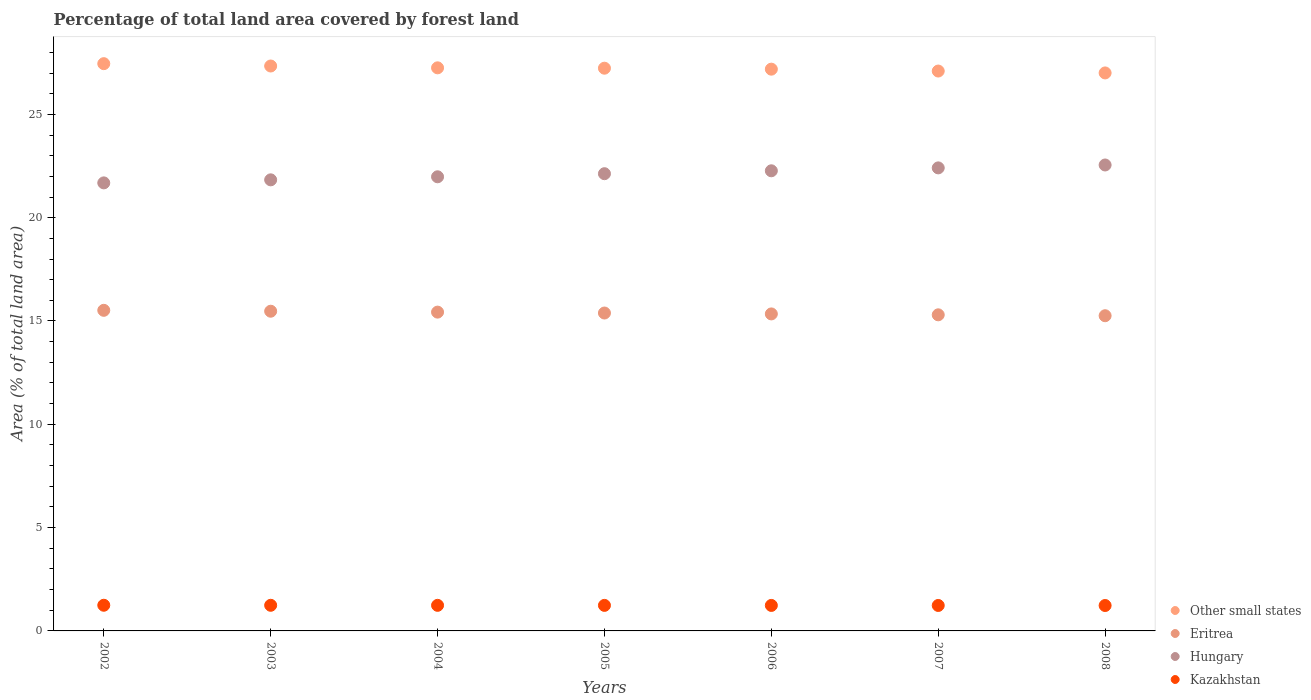How many different coloured dotlines are there?
Make the answer very short. 4. Is the number of dotlines equal to the number of legend labels?
Offer a very short reply. Yes. What is the percentage of forest land in Eritrea in 2002?
Give a very brief answer. 15.52. Across all years, what is the maximum percentage of forest land in Kazakhstan?
Your answer should be compact. 1.24. Across all years, what is the minimum percentage of forest land in Hungary?
Ensure brevity in your answer.  21.68. In which year was the percentage of forest land in Hungary maximum?
Give a very brief answer. 2008. In which year was the percentage of forest land in Kazakhstan minimum?
Your answer should be compact. 2008. What is the total percentage of forest land in Hungary in the graph?
Provide a short and direct response. 154.86. What is the difference between the percentage of forest land in Kazakhstan in 2002 and that in 2003?
Provide a succinct answer. 0. What is the difference between the percentage of forest land in Hungary in 2004 and the percentage of forest land in Other small states in 2008?
Provide a succinct answer. -5.03. What is the average percentage of forest land in Kazakhstan per year?
Make the answer very short. 1.24. In the year 2006, what is the difference between the percentage of forest land in Eritrea and percentage of forest land in Other small states?
Offer a very short reply. -11.85. What is the ratio of the percentage of forest land in Hungary in 2003 to that in 2007?
Make the answer very short. 0.97. Is the difference between the percentage of forest land in Eritrea in 2002 and 2005 greater than the difference between the percentage of forest land in Other small states in 2002 and 2005?
Ensure brevity in your answer.  No. What is the difference between the highest and the second highest percentage of forest land in Hungary?
Offer a terse response. 0.14. What is the difference between the highest and the lowest percentage of forest land in Eritrea?
Keep it short and to the point. 0.26. Is the sum of the percentage of forest land in Other small states in 2003 and 2005 greater than the maximum percentage of forest land in Hungary across all years?
Your answer should be very brief. Yes. Does the percentage of forest land in Other small states monotonically increase over the years?
Your answer should be compact. No. Is the percentage of forest land in Hungary strictly greater than the percentage of forest land in Other small states over the years?
Keep it short and to the point. No. Does the graph contain grids?
Provide a succinct answer. No. Where does the legend appear in the graph?
Make the answer very short. Bottom right. How many legend labels are there?
Provide a succinct answer. 4. How are the legend labels stacked?
Your answer should be very brief. Vertical. What is the title of the graph?
Keep it short and to the point. Percentage of total land area covered by forest land. What is the label or title of the X-axis?
Your answer should be very brief. Years. What is the label or title of the Y-axis?
Provide a succinct answer. Area (% of total land area). What is the Area (% of total land area) in Other small states in 2002?
Give a very brief answer. 27.45. What is the Area (% of total land area) of Eritrea in 2002?
Give a very brief answer. 15.52. What is the Area (% of total land area) in Hungary in 2002?
Provide a short and direct response. 21.68. What is the Area (% of total land area) in Kazakhstan in 2002?
Your response must be concise. 1.24. What is the Area (% of total land area) in Other small states in 2003?
Your response must be concise. 27.34. What is the Area (% of total land area) of Eritrea in 2003?
Your answer should be very brief. 15.47. What is the Area (% of total land area) in Hungary in 2003?
Offer a very short reply. 21.83. What is the Area (% of total land area) of Kazakhstan in 2003?
Offer a terse response. 1.24. What is the Area (% of total land area) in Other small states in 2004?
Ensure brevity in your answer.  27.25. What is the Area (% of total land area) in Eritrea in 2004?
Provide a succinct answer. 15.43. What is the Area (% of total land area) in Hungary in 2004?
Offer a very short reply. 21.98. What is the Area (% of total land area) of Kazakhstan in 2004?
Offer a terse response. 1.24. What is the Area (% of total land area) in Other small states in 2005?
Ensure brevity in your answer.  27.24. What is the Area (% of total land area) of Eritrea in 2005?
Make the answer very short. 15.39. What is the Area (% of total land area) in Hungary in 2005?
Provide a short and direct response. 22.13. What is the Area (% of total land area) in Kazakhstan in 2005?
Provide a short and direct response. 1.24. What is the Area (% of total land area) in Other small states in 2006?
Give a very brief answer. 27.19. What is the Area (% of total land area) of Eritrea in 2006?
Your answer should be compact. 15.34. What is the Area (% of total land area) in Hungary in 2006?
Ensure brevity in your answer.  22.27. What is the Area (% of total land area) of Kazakhstan in 2006?
Your answer should be compact. 1.23. What is the Area (% of total land area) of Other small states in 2007?
Keep it short and to the point. 27.1. What is the Area (% of total land area) in Eritrea in 2007?
Keep it short and to the point. 15.3. What is the Area (% of total land area) of Hungary in 2007?
Offer a very short reply. 22.41. What is the Area (% of total land area) of Kazakhstan in 2007?
Make the answer very short. 1.23. What is the Area (% of total land area) of Other small states in 2008?
Your response must be concise. 27.01. What is the Area (% of total land area) in Eritrea in 2008?
Your answer should be very brief. 15.26. What is the Area (% of total land area) in Hungary in 2008?
Give a very brief answer. 22.55. What is the Area (% of total land area) in Kazakhstan in 2008?
Offer a very short reply. 1.23. Across all years, what is the maximum Area (% of total land area) of Other small states?
Make the answer very short. 27.45. Across all years, what is the maximum Area (% of total land area) of Eritrea?
Offer a very short reply. 15.52. Across all years, what is the maximum Area (% of total land area) in Hungary?
Make the answer very short. 22.55. Across all years, what is the maximum Area (% of total land area) of Kazakhstan?
Provide a short and direct response. 1.24. Across all years, what is the minimum Area (% of total land area) of Other small states?
Give a very brief answer. 27.01. Across all years, what is the minimum Area (% of total land area) in Eritrea?
Your answer should be very brief. 15.26. Across all years, what is the minimum Area (% of total land area) in Hungary?
Offer a very short reply. 21.68. Across all years, what is the minimum Area (% of total land area) in Kazakhstan?
Your response must be concise. 1.23. What is the total Area (% of total land area) of Other small states in the graph?
Your answer should be very brief. 190.58. What is the total Area (% of total land area) in Eritrea in the graph?
Your response must be concise. 107.7. What is the total Area (% of total land area) of Hungary in the graph?
Provide a succinct answer. 154.86. What is the total Area (% of total land area) of Kazakhstan in the graph?
Provide a succinct answer. 8.65. What is the difference between the Area (% of total land area) in Other small states in 2002 and that in 2003?
Offer a terse response. 0.11. What is the difference between the Area (% of total land area) in Eritrea in 2002 and that in 2003?
Provide a succinct answer. 0.04. What is the difference between the Area (% of total land area) of Hungary in 2002 and that in 2003?
Your answer should be very brief. -0.15. What is the difference between the Area (% of total land area) in Kazakhstan in 2002 and that in 2003?
Your response must be concise. 0. What is the difference between the Area (% of total land area) in Other small states in 2002 and that in 2004?
Offer a very short reply. 0.2. What is the difference between the Area (% of total land area) of Eritrea in 2002 and that in 2004?
Provide a short and direct response. 0.09. What is the difference between the Area (% of total land area) of Hungary in 2002 and that in 2004?
Keep it short and to the point. -0.29. What is the difference between the Area (% of total land area) of Kazakhstan in 2002 and that in 2004?
Provide a succinct answer. 0. What is the difference between the Area (% of total land area) of Other small states in 2002 and that in 2005?
Offer a terse response. 0.22. What is the difference between the Area (% of total land area) of Eritrea in 2002 and that in 2005?
Offer a terse response. 0.13. What is the difference between the Area (% of total land area) in Hungary in 2002 and that in 2005?
Provide a short and direct response. -0.44. What is the difference between the Area (% of total land area) in Kazakhstan in 2002 and that in 2005?
Make the answer very short. 0.01. What is the difference between the Area (% of total land area) in Other small states in 2002 and that in 2006?
Your response must be concise. 0.27. What is the difference between the Area (% of total land area) of Eritrea in 2002 and that in 2006?
Make the answer very short. 0.17. What is the difference between the Area (% of total land area) of Hungary in 2002 and that in 2006?
Your response must be concise. -0.58. What is the difference between the Area (% of total land area) of Kazakhstan in 2002 and that in 2006?
Provide a succinct answer. 0.01. What is the difference between the Area (% of total land area) of Other small states in 2002 and that in 2007?
Keep it short and to the point. 0.36. What is the difference between the Area (% of total land area) of Eritrea in 2002 and that in 2007?
Offer a very short reply. 0.22. What is the difference between the Area (% of total land area) in Hungary in 2002 and that in 2007?
Provide a short and direct response. -0.73. What is the difference between the Area (% of total land area) of Kazakhstan in 2002 and that in 2007?
Provide a succinct answer. 0.01. What is the difference between the Area (% of total land area) of Other small states in 2002 and that in 2008?
Offer a very short reply. 0.45. What is the difference between the Area (% of total land area) in Eritrea in 2002 and that in 2008?
Provide a short and direct response. 0.26. What is the difference between the Area (% of total land area) in Hungary in 2002 and that in 2008?
Make the answer very short. -0.87. What is the difference between the Area (% of total land area) of Kazakhstan in 2002 and that in 2008?
Keep it short and to the point. 0.01. What is the difference between the Area (% of total land area) of Other small states in 2003 and that in 2004?
Provide a succinct answer. 0.09. What is the difference between the Area (% of total land area) in Eritrea in 2003 and that in 2004?
Your response must be concise. 0.04. What is the difference between the Area (% of total land area) in Hungary in 2003 and that in 2004?
Ensure brevity in your answer.  -0.15. What is the difference between the Area (% of total land area) of Kazakhstan in 2003 and that in 2004?
Offer a terse response. 0. What is the difference between the Area (% of total land area) in Other small states in 2003 and that in 2005?
Offer a very short reply. 0.11. What is the difference between the Area (% of total land area) in Eritrea in 2003 and that in 2005?
Provide a short and direct response. 0.09. What is the difference between the Area (% of total land area) of Hungary in 2003 and that in 2005?
Your answer should be very brief. -0.3. What is the difference between the Area (% of total land area) in Kazakhstan in 2003 and that in 2005?
Offer a very short reply. 0. What is the difference between the Area (% of total land area) in Other small states in 2003 and that in 2006?
Your answer should be very brief. 0.15. What is the difference between the Area (% of total land area) of Eritrea in 2003 and that in 2006?
Your answer should be compact. 0.13. What is the difference between the Area (% of total land area) of Hungary in 2003 and that in 2006?
Make the answer very short. -0.44. What is the difference between the Area (% of total land area) in Kazakhstan in 2003 and that in 2006?
Ensure brevity in your answer.  0.01. What is the difference between the Area (% of total land area) in Other small states in 2003 and that in 2007?
Your response must be concise. 0.24. What is the difference between the Area (% of total land area) of Eritrea in 2003 and that in 2007?
Make the answer very short. 0.17. What is the difference between the Area (% of total land area) of Hungary in 2003 and that in 2007?
Your response must be concise. -0.58. What is the difference between the Area (% of total land area) of Kazakhstan in 2003 and that in 2007?
Make the answer very short. 0.01. What is the difference between the Area (% of total land area) in Other small states in 2003 and that in 2008?
Keep it short and to the point. 0.34. What is the difference between the Area (% of total land area) of Eritrea in 2003 and that in 2008?
Your answer should be very brief. 0.22. What is the difference between the Area (% of total land area) of Hungary in 2003 and that in 2008?
Offer a very short reply. -0.72. What is the difference between the Area (% of total land area) of Kazakhstan in 2003 and that in 2008?
Provide a succinct answer. 0.01. What is the difference between the Area (% of total land area) in Other small states in 2004 and that in 2005?
Give a very brief answer. 0.02. What is the difference between the Area (% of total land area) of Eritrea in 2004 and that in 2005?
Your answer should be compact. 0.04. What is the difference between the Area (% of total land area) in Hungary in 2004 and that in 2005?
Offer a terse response. -0.15. What is the difference between the Area (% of total land area) in Kazakhstan in 2004 and that in 2005?
Your answer should be very brief. 0. What is the difference between the Area (% of total land area) in Other small states in 2004 and that in 2006?
Your answer should be compact. 0.06. What is the difference between the Area (% of total land area) of Eritrea in 2004 and that in 2006?
Offer a very short reply. 0.09. What is the difference between the Area (% of total land area) of Hungary in 2004 and that in 2006?
Your response must be concise. -0.29. What is the difference between the Area (% of total land area) in Kazakhstan in 2004 and that in 2006?
Make the answer very short. 0. What is the difference between the Area (% of total land area) in Other small states in 2004 and that in 2007?
Make the answer very short. 0.16. What is the difference between the Area (% of total land area) of Eritrea in 2004 and that in 2007?
Offer a terse response. 0.13. What is the difference between the Area (% of total land area) of Hungary in 2004 and that in 2007?
Your answer should be very brief. -0.43. What is the difference between the Area (% of total land area) in Kazakhstan in 2004 and that in 2007?
Offer a very short reply. 0.01. What is the difference between the Area (% of total land area) of Other small states in 2004 and that in 2008?
Keep it short and to the point. 0.25. What is the difference between the Area (% of total land area) in Eritrea in 2004 and that in 2008?
Provide a short and direct response. 0.17. What is the difference between the Area (% of total land area) of Hungary in 2004 and that in 2008?
Make the answer very short. -0.57. What is the difference between the Area (% of total land area) of Kazakhstan in 2004 and that in 2008?
Your answer should be compact. 0.01. What is the difference between the Area (% of total land area) of Other small states in 2005 and that in 2006?
Ensure brevity in your answer.  0.05. What is the difference between the Area (% of total land area) of Eritrea in 2005 and that in 2006?
Provide a short and direct response. 0.04. What is the difference between the Area (% of total land area) in Hungary in 2005 and that in 2006?
Offer a very short reply. -0.14. What is the difference between the Area (% of total land area) in Kazakhstan in 2005 and that in 2006?
Provide a succinct answer. 0. What is the difference between the Area (% of total land area) in Other small states in 2005 and that in 2007?
Offer a very short reply. 0.14. What is the difference between the Area (% of total land area) in Eritrea in 2005 and that in 2007?
Keep it short and to the point. 0.09. What is the difference between the Area (% of total land area) in Hungary in 2005 and that in 2007?
Give a very brief answer. -0.28. What is the difference between the Area (% of total land area) in Kazakhstan in 2005 and that in 2007?
Your answer should be very brief. 0. What is the difference between the Area (% of total land area) of Other small states in 2005 and that in 2008?
Offer a very short reply. 0.23. What is the difference between the Area (% of total land area) of Eritrea in 2005 and that in 2008?
Ensure brevity in your answer.  0.13. What is the difference between the Area (% of total land area) of Hungary in 2005 and that in 2008?
Keep it short and to the point. -0.42. What is the difference between the Area (% of total land area) of Kazakhstan in 2005 and that in 2008?
Your response must be concise. 0.01. What is the difference between the Area (% of total land area) of Other small states in 2006 and that in 2007?
Ensure brevity in your answer.  0.09. What is the difference between the Area (% of total land area) in Eritrea in 2006 and that in 2007?
Ensure brevity in your answer.  0.04. What is the difference between the Area (% of total land area) of Hungary in 2006 and that in 2007?
Provide a short and direct response. -0.14. What is the difference between the Area (% of total land area) of Kazakhstan in 2006 and that in 2007?
Make the answer very short. 0. What is the difference between the Area (% of total land area) of Other small states in 2006 and that in 2008?
Provide a succinct answer. 0.18. What is the difference between the Area (% of total land area) in Eritrea in 2006 and that in 2008?
Your response must be concise. 0.09. What is the difference between the Area (% of total land area) of Hungary in 2006 and that in 2008?
Make the answer very short. -0.28. What is the difference between the Area (% of total land area) of Kazakhstan in 2006 and that in 2008?
Offer a very short reply. 0. What is the difference between the Area (% of total land area) in Other small states in 2007 and that in 2008?
Offer a terse response. 0.09. What is the difference between the Area (% of total land area) in Eritrea in 2007 and that in 2008?
Ensure brevity in your answer.  0.04. What is the difference between the Area (% of total land area) in Hungary in 2007 and that in 2008?
Your answer should be very brief. -0.14. What is the difference between the Area (% of total land area) in Kazakhstan in 2007 and that in 2008?
Keep it short and to the point. 0. What is the difference between the Area (% of total land area) of Other small states in 2002 and the Area (% of total land area) of Eritrea in 2003?
Provide a short and direct response. 11.98. What is the difference between the Area (% of total land area) of Other small states in 2002 and the Area (% of total land area) of Hungary in 2003?
Keep it short and to the point. 5.62. What is the difference between the Area (% of total land area) in Other small states in 2002 and the Area (% of total land area) in Kazakhstan in 2003?
Make the answer very short. 26.21. What is the difference between the Area (% of total land area) in Eritrea in 2002 and the Area (% of total land area) in Hungary in 2003?
Offer a terse response. -6.32. What is the difference between the Area (% of total land area) of Eritrea in 2002 and the Area (% of total land area) of Kazakhstan in 2003?
Your response must be concise. 14.28. What is the difference between the Area (% of total land area) in Hungary in 2002 and the Area (% of total land area) in Kazakhstan in 2003?
Keep it short and to the point. 20.44. What is the difference between the Area (% of total land area) of Other small states in 2002 and the Area (% of total land area) of Eritrea in 2004?
Provide a succinct answer. 12.03. What is the difference between the Area (% of total land area) in Other small states in 2002 and the Area (% of total land area) in Hungary in 2004?
Keep it short and to the point. 5.48. What is the difference between the Area (% of total land area) of Other small states in 2002 and the Area (% of total land area) of Kazakhstan in 2004?
Ensure brevity in your answer.  26.22. What is the difference between the Area (% of total land area) in Eritrea in 2002 and the Area (% of total land area) in Hungary in 2004?
Your answer should be compact. -6.46. What is the difference between the Area (% of total land area) in Eritrea in 2002 and the Area (% of total land area) in Kazakhstan in 2004?
Provide a short and direct response. 14.28. What is the difference between the Area (% of total land area) in Hungary in 2002 and the Area (% of total land area) in Kazakhstan in 2004?
Offer a very short reply. 20.45. What is the difference between the Area (% of total land area) in Other small states in 2002 and the Area (% of total land area) in Eritrea in 2005?
Ensure brevity in your answer.  12.07. What is the difference between the Area (% of total land area) of Other small states in 2002 and the Area (% of total land area) of Hungary in 2005?
Ensure brevity in your answer.  5.33. What is the difference between the Area (% of total land area) of Other small states in 2002 and the Area (% of total land area) of Kazakhstan in 2005?
Offer a very short reply. 26.22. What is the difference between the Area (% of total land area) in Eritrea in 2002 and the Area (% of total land area) in Hungary in 2005?
Provide a short and direct response. -6.61. What is the difference between the Area (% of total land area) of Eritrea in 2002 and the Area (% of total land area) of Kazakhstan in 2005?
Ensure brevity in your answer.  14.28. What is the difference between the Area (% of total land area) of Hungary in 2002 and the Area (% of total land area) of Kazakhstan in 2005?
Your response must be concise. 20.45. What is the difference between the Area (% of total land area) of Other small states in 2002 and the Area (% of total land area) of Eritrea in 2006?
Give a very brief answer. 12.11. What is the difference between the Area (% of total land area) of Other small states in 2002 and the Area (% of total land area) of Hungary in 2006?
Offer a terse response. 5.18. What is the difference between the Area (% of total land area) of Other small states in 2002 and the Area (% of total land area) of Kazakhstan in 2006?
Provide a succinct answer. 26.22. What is the difference between the Area (% of total land area) in Eritrea in 2002 and the Area (% of total land area) in Hungary in 2006?
Keep it short and to the point. -6.75. What is the difference between the Area (% of total land area) in Eritrea in 2002 and the Area (% of total land area) in Kazakhstan in 2006?
Keep it short and to the point. 14.28. What is the difference between the Area (% of total land area) of Hungary in 2002 and the Area (% of total land area) of Kazakhstan in 2006?
Your response must be concise. 20.45. What is the difference between the Area (% of total land area) in Other small states in 2002 and the Area (% of total land area) in Eritrea in 2007?
Keep it short and to the point. 12.16. What is the difference between the Area (% of total land area) of Other small states in 2002 and the Area (% of total land area) of Hungary in 2007?
Offer a very short reply. 5.04. What is the difference between the Area (% of total land area) in Other small states in 2002 and the Area (% of total land area) in Kazakhstan in 2007?
Offer a very short reply. 26.22. What is the difference between the Area (% of total land area) in Eritrea in 2002 and the Area (% of total land area) in Hungary in 2007?
Keep it short and to the point. -6.89. What is the difference between the Area (% of total land area) of Eritrea in 2002 and the Area (% of total land area) of Kazakhstan in 2007?
Give a very brief answer. 14.28. What is the difference between the Area (% of total land area) of Hungary in 2002 and the Area (% of total land area) of Kazakhstan in 2007?
Keep it short and to the point. 20.45. What is the difference between the Area (% of total land area) of Other small states in 2002 and the Area (% of total land area) of Eritrea in 2008?
Your answer should be very brief. 12.2. What is the difference between the Area (% of total land area) of Other small states in 2002 and the Area (% of total land area) of Hungary in 2008?
Your answer should be compact. 4.9. What is the difference between the Area (% of total land area) in Other small states in 2002 and the Area (% of total land area) in Kazakhstan in 2008?
Provide a short and direct response. 26.22. What is the difference between the Area (% of total land area) of Eritrea in 2002 and the Area (% of total land area) of Hungary in 2008?
Your response must be concise. -7.03. What is the difference between the Area (% of total land area) in Eritrea in 2002 and the Area (% of total land area) in Kazakhstan in 2008?
Offer a very short reply. 14.29. What is the difference between the Area (% of total land area) in Hungary in 2002 and the Area (% of total land area) in Kazakhstan in 2008?
Offer a terse response. 20.46. What is the difference between the Area (% of total land area) in Other small states in 2003 and the Area (% of total land area) in Eritrea in 2004?
Ensure brevity in your answer.  11.91. What is the difference between the Area (% of total land area) of Other small states in 2003 and the Area (% of total land area) of Hungary in 2004?
Provide a short and direct response. 5.36. What is the difference between the Area (% of total land area) of Other small states in 2003 and the Area (% of total land area) of Kazakhstan in 2004?
Ensure brevity in your answer.  26.1. What is the difference between the Area (% of total land area) in Eritrea in 2003 and the Area (% of total land area) in Hungary in 2004?
Offer a terse response. -6.51. What is the difference between the Area (% of total land area) in Eritrea in 2003 and the Area (% of total land area) in Kazakhstan in 2004?
Provide a succinct answer. 14.24. What is the difference between the Area (% of total land area) of Hungary in 2003 and the Area (% of total land area) of Kazakhstan in 2004?
Provide a short and direct response. 20.59. What is the difference between the Area (% of total land area) in Other small states in 2003 and the Area (% of total land area) in Eritrea in 2005?
Keep it short and to the point. 11.96. What is the difference between the Area (% of total land area) of Other small states in 2003 and the Area (% of total land area) of Hungary in 2005?
Give a very brief answer. 5.21. What is the difference between the Area (% of total land area) in Other small states in 2003 and the Area (% of total land area) in Kazakhstan in 2005?
Provide a succinct answer. 26.11. What is the difference between the Area (% of total land area) in Eritrea in 2003 and the Area (% of total land area) in Hungary in 2005?
Offer a terse response. -6.66. What is the difference between the Area (% of total land area) in Eritrea in 2003 and the Area (% of total land area) in Kazakhstan in 2005?
Ensure brevity in your answer.  14.24. What is the difference between the Area (% of total land area) in Hungary in 2003 and the Area (% of total land area) in Kazakhstan in 2005?
Ensure brevity in your answer.  20.6. What is the difference between the Area (% of total land area) in Other small states in 2003 and the Area (% of total land area) in Eritrea in 2006?
Ensure brevity in your answer.  12. What is the difference between the Area (% of total land area) in Other small states in 2003 and the Area (% of total land area) in Hungary in 2006?
Make the answer very short. 5.07. What is the difference between the Area (% of total land area) in Other small states in 2003 and the Area (% of total land area) in Kazakhstan in 2006?
Your response must be concise. 26.11. What is the difference between the Area (% of total land area) in Eritrea in 2003 and the Area (% of total land area) in Hungary in 2006?
Provide a short and direct response. -6.8. What is the difference between the Area (% of total land area) in Eritrea in 2003 and the Area (% of total land area) in Kazakhstan in 2006?
Make the answer very short. 14.24. What is the difference between the Area (% of total land area) of Hungary in 2003 and the Area (% of total land area) of Kazakhstan in 2006?
Your answer should be compact. 20.6. What is the difference between the Area (% of total land area) in Other small states in 2003 and the Area (% of total land area) in Eritrea in 2007?
Make the answer very short. 12.04. What is the difference between the Area (% of total land area) in Other small states in 2003 and the Area (% of total land area) in Hungary in 2007?
Your response must be concise. 4.93. What is the difference between the Area (% of total land area) of Other small states in 2003 and the Area (% of total land area) of Kazakhstan in 2007?
Your answer should be compact. 26.11. What is the difference between the Area (% of total land area) of Eritrea in 2003 and the Area (% of total land area) of Hungary in 2007?
Offer a terse response. -6.94. What is the difference between the Area (% of total land area) of Eritrea in 2003 and the Area (% of total land area) of Kazakhstan in 2007?
Make the answer very short. 14.24. What is the difference between the Area (% of total land area) in Hungary in 2003 and the Area (% of total land area) in Kazakhstan in 2007?
Offer a very short reply. 20.6. What is the difference between the Area (% of total land area) in Other small states in 2003 and the Area (% of total land area) in Eritrea in 2008?
Make the answer very short. 12.09. What is the difference between the Area (% of total land area) of Other small states in 2003 and the Area (% of total land area) of Hungary in 2008?
Provide a short and direct response. 4.79. What is the difference between the Area (% of total land area) of Other small states in 2003 and the Area (% of total land area) of Kazakhstan in 2008?
Provide a succinct answer. 26.11. What is the difference between the Area (% of total land area) of Eritrea in 2003 and the Area (% of total land area) of Hungary in 2008?
Provide a succinct answer. -7.08. What is the difference between the Area (% of total land area) of Eritrea in 2003 and the Area (% of total land area) of Kazakhstan in 2008?
Your response must be concise. 14.24. What is the difference between the Area (% of total land area) of Hungary in 2003 and the Area (% of total land area) of Kazakhstan in 2008?
Offer a terse response. 20.6. What is the difference between the Area (% of total land area) in Other small states in 2004 and the Area (% of total land area) in Eritrea in 2005?
Offer a very short reply. 11.87. What is the difference between the Area (% of total land area) of Other small states in 2004 and the Area (% of total land area) of Hungary in 2005?
Your answer should be compact. 5.12. What is the difference between the Area (% of total land area) in Other small states in 2004 and the Area (% of total land area) in Kazakhstan in 2005?
Make the answer very short. 26.02. What is the difference between the Area (% of total land area) in Eritrea in 2004 and the Area (% of total land area) in Hungary in 2005?
Provide a succinct answer. -6.7. What is the difference between the Area (% of total land area) of Eritrea in 2004 and the Area (% of total land area) of Kazakhstan in 2005?
Provide a succinct answer. 14.19. What is the difference between the Area (% of total land area) of Hungary in 2004 and the Area (% of total land area) of Kazakhstan in 2005?
Make the answer very short. 20.74. What is the difference between the Area (% of total land area) in Other small states in 2004 and the Area (% of total land area) in Eritrea in 2006?
Provide a short and direct response. 11.91. What is the difference between the Area (% of total land area) of Other small states in 2004 and the Area (% of total land area) of Hungary in 2006?
Your response must be concise. 4.98. What is the difference between the Area (% of total land area) in Other small states in 2004 and the Area (% of total land area) in Kazakhstan in 2006?
Your response must be concise. 26.02. What is the difference between the Area (% of total land area) in Eritrea in 2004 and the Area (% of total land area) in Hungary in 2006?
Provide a short and direct response. -6.84. What is the difference between the Area (% of total land area) in Eritrea in 2004 and the Area (% of total land area) in Kazakhstan in 2006?
Your answer should be compact. 14.2. What is the difference between the Area (% of total land area) in Hungary in 2004 and the Area (% of total land area) in Kazakhstan in 2006?
Provide a succinct answer. 20.75. What is the difference between the Area (% of total land area) of Other small states in 2004 and the Area (% of total land area) of Eritrea in 2007?
Offer a terse response. 11.95. What is the difference between the Area (% of total land area) of Other small states in 2004 and the Area (% of total land area) of Hungary in 2007?
Give a very brief answer. 4.84. What is the difference between the Area (% of total land area) in Other small states in 2004 and the Area (% of total land area) in Kazakhstan in 2007?
Offer a very short reply. 26.02. What is the difference between the Area (% of total land area) of Eritrea in 2004 and the Area (% of total land area) of Hungary in 2007?
Offer a very short reply. -6.98. What is the difference between the Area (% of total land area) in Eritrea in 2004 and the Area (% of total land area) in Kazakhstan in 2007?
Offer a terse response. 14.2. What is the difference between the Area (% of total land area) in Hungary in 2004 and the Area (% of total land area) in Kazakhstan in 2007?
Your answer should be compact. 20.75. What is the difference between the Area (% of total land area) of Other small states in 2004 and the Area (% of total land area) of Eritrea in 2008?
Offer a very short reply. 12. What is the difference between the Area (% of total land area) in Other small states in 2004 and the Area (% of total land area) in Hungary in 2008?
Your response must be concise. 4.7. What is the difference between the Area (% of total land area) of Other small states in 2004 and the Area (% of total land area) of Kazakhstan in 2008?
Your answer should be very brief. 26.02. What is the difference between the Area (% of total land area) of Eritrea in 2004 and the Area (% of total land area) of Hungary in 2008?
Ensure brevity in your answer.  -7.12. What is the difference between the Area (% of total land area) in Eritrea in 2004 and the Area (% of total land area) in Kazakhstan in 2008?
Offer a very short reply. 14.2. What is the difference between the Area (% of total land area) in Hungary in 2004 and the Area (% of total land area) in Kazakhstan in 2008?
Provide a succinct answer. 20.75. What is the difference between the Area (% of total land area) in Other small states in 2005 and the Area (% of total land area) in Eritrea in 2006?
Your response must be concise. 11.89. What is the difference between the Area (% of total land area) of Other small states in 2005 and the Area (% of total land area) of Hungary in 2006?
Your answer should be very brief. 4.97. What is the difference between the Area (% of total land area) of Other small states in 2005 and the Area (% of total land area) of Kazakhstan in 2006?
Give a very brief answer. 26. What is the difference between the Area (% of total land area) of Eritrea in 2005 and the Area (% of total land area) of Hungary in 2006?
Provide a succinct answer. -6.88. What is the difference between the Area (% of total land area) of Eritrea in 2005 and the Area (% of total land area) of Kazakhstan in 2006?
Ensure brevity in your answer.  14.15. What is the difference between the Area (% of total land area) in Hungary in 2005 and the Area (% of total land area) in Kazakhstan in 2006?
Your answer should be compact. 20.9. What is the difference between the Area (% of total land area) of Other small states in 2005 and the Area (% of total land area) of Eritrea in 2007?
Your answer should be compact. 11.94. What is the difference between the Area (% of total land area) of Other small states in 2005 and the Area (% of total land area) of Hungary in 2007?
Make the answer very short. 4.83. What is the difference between the Area (% of total land area) of Other small states in 2005 and the Area (% of total land area) of Kazakhstan in 2007?
Offer a very short reply. 26. What is the difference between the Area (% of total land area) of Eritrea in 2005 and the Area (% of total land area) of Hungary in 2007?
Your response must be concise. -7.02. What is the difference between the Area (% of total land area) of Eritrea in 2005 and the Area (% of total land area) of Kazakhstan in 2007?
Offer a terse response. 14.15. What is the difference between the Area (% of total land area) of Hungary in 2005 and the Area (% of total land area) of Kazakhstan in 2007?
Keep it short and to the point. 20.9. What is the difference between the Area (% of total land area) of Other small states in 2005 and the Area (% of total land area) of Eritrea in 2008?
Offer a very short reply. 11.98. What is the difference between the Area (% of total land area) in Other small states in 2005 and the Area (% of total land area) in Hungary in 2008?
Offer a terse response. 4.68. What is the difference between the Area (% of total land area) in Other small states in 2005 and the Area (% of total land area) in Kazakhstan in 2008?
Give a very brief answer. 26.01. What is the difference between the Area (% of total land area) in Eritrea in 2005 and the Area (% of total land area) in Hungary in 2008?
Offer a terse response. -7.16. What is the difference between the Area (% of total land area) of Eritrea in 2005 and the Area (% of total land area) of Kazakhstan in 2008?
Your answer should be very brief. 14.16. What is the difference between the Area (% of total land area) of Hungary in 2005 and the Area (% of total land area) of Kazakhstan in 2008?
Make the answer very short. 20.9. What is the difference between the Area (% of total land area) of Other small states in 2006 and the Area (% of total land area) of Eritrea in 2007?
Your response must be concise. 11.89. What is the difference between the Area (% of total land area) in Other small states in 2006 and the Area (% of total land area) in Hungary in 2007?
Give a very brief answer. 4.78. What is the difference between the Area (% of total land area) of Other small states in 2006 and the Area (% of total land area) of Kazakhstan in 2007?
Give a very brief answer. 25.96. What is the difference between the Area (% of total land area) of Eritrea in 2006 and the Area (% of total land area) of Hungary in 2007?
Provide a succinct answer. -7.07. What is the difference between the Area (% of total land area) in Eritrea in 2006 and the Area (% of total land area) in Kazakhstan in 2007?
Your answer should be very brief. 14.11. What is the difference between the Area (% of total land area) in Hungary in 2006 and the Area (% of total land area) in Kazakhstan in 2007?
Provide a short and direct response. 21.04. What is the difference between the Area (% of total land area) in Other small states in 2006 and the Area (% of total land area) in Eritrea in 2008?
Ensure brevity in your answer.  11.93. What is the difference between the Area (% of total land area) of Other small states in 2006 and the Area (% of total land area) of Hungary in 2008?
Your answer should be very brief. 4.64. What is the difference between the Area (% of total land area) in Other small states in 2006 and the Area (% of total land area) in Kazakhstan in 2008?
Your answer should be very brief. 25.96. What is the difference between the Area (% of total land area) in Eritrea in 2006 and the Area (% of total land area) in Hungary in 2008?
Your response must be concise. -7.21. What is the difference between the Area (% of total land area) of Eritrea in 2006 and the Area (% of total land area) of Kazakhstan in 2008?
Provide a succinct answer. 14.11. What is the difference between the Area (% of total land area) of Hungary in 2006 and the Area (% of total land area) of Kazakhstan in 2008?
Offer a terse response. 21.04. What is the difference between the Area (% of total land area) in Other small states in 2007 and the Area (% of total land area) in Eritrea in 2008?
Keep it short and to the point. 11.84. What is the difference between the Area (% of total land area) of Other small states in 2007 and the Area (% of total land area) of Hungary in 2008?
Make the answer very short. 4.55. What is the difference between the Area (% of total land area) of Other small states in 2007 and the Area (% of total land area) of Kazakhstan in 2008?
Your answer should be compact. 25.87. What is the difference between the Area (% of total land area) of Eritrea in 2007 and the Area (% of total land area) of Hungary in 2008?
Offer a terse response. -7.25. What is the difference between the Area (% of total land area) in Eritrea in 2007 and the Area (% of total land area) in Kazakhstan in 2008?
Your answer should be very brief. 14.07. What is the difference between the Area (% of total land area) of Hungary in 2007 and the Area (% of total land area) of Kazakhstan in 2008?
Offer a very short reply. 21.18. What is the average Area (% of total land area) of Other small states per year?
Provide a short and direct response. 27.23. What is the average Area (% of total land area) of Eritrea per year?
Ensure brevity in your answer.  15.39. What is the average Area (% of total land area) of Hungary per year?
Your answer should be compact. 22.12. What is the average Area (% of total land area) in Kazakhstan per year?
Your answer should be compact. 1.24. In the year 2002, what is the difference between the Area (% of total land area) of Other small states and Area (% of total land area) of Eritrea?
Ensure brevity in your answer.  11.94. In the year 2002, what is the difference between the Area (% of total land area) of Other small states and Area (% of total land area) of Hungary?
Your answer should be very brief. 5.77. In the year 2002, what is the difference between the Area (% of total land area) in Other small states and Area (% of total land area) in Kazakhstan?
Your answer should be very brief. 26.21. In the year 2002, what is the difference between the Area (% of total land area) in Eritrea and Area (% of total land area) in Hungary?
Provide a short and direct response. -6.17. In the year 2002, what is the difference between the Area (% of total land area) of Eritrea and Area (% of total land area) of Kazakhstan?
Provide a succinct answer. 14.27. In the year 2002, what is the difference between the Area (% of total land area) of Hungary and Area (% of total land area) of Kazakhstan?
Ensure brevity in your answer.  20.44. In the year 2003, what is the difference between the Area (% of total land area) in Other small states and Area (% of total land area) in Eritrea?
Provide a short and direct response. 11.87. In the year 2003, what is the difference between the Area (% of total land area) in Other small states and Area (% of total land area) in Hungary?
Your answer should be compact. 5.51. In the year 2003, what is the difference between the Area (% of total land area) in Other small states and Area (% of total land area) in Kazakhstan?
Offer a very short reply. 26.1. In the year 2003, what is the difference between the Area (% of total land area) in Eritrea and Area (% of total land area) in Hungary?
Your answer should be very brief. -6.36. In the year 2003, what is the difference between the Area (% of total land area) of Eritrea and Area (% of total land area) of Kazakhstan?
Give a very brief answer. 14.23. In the year 2003, what is the difference between the Area (% of total land area) of Hungary and Area (% of total land area) of Kazakhstan?
Your answer should be compact. 20.59. In the year 2004, what is the difference between the Area (% of total land area) of Other small states and Area (% of total land area) of Eritrea?
Keep it short and to the point. 11.82. In the year 2004, what is the difference between the Area (% of total land area) of Other small states and Area (% of total land area) of Hungary?
Provide a succinct answer. 5.27. In the year 2004, what is the difference between the Area (% of total land area) of Other small states and Area (% of total land area) of Kazakhstan?
Your response must be concise. 26.02. In the year 2004, what is the difference between the Area (% of total land area) in Eritrea and Area (% of total land area) in Hungary?
Your answer should be compact. -6.55. In the year 2004, what is the difference between the Area (% of total land area) of Eritrea and Area (% of total land area) of Kazakhstan?
Offer a very short reply. 14.19. In the year 2004, what is the difference between the Area (% of total land area) of Hungary and Area (% of total land area) of Kazakhstan?
Your answer should be compact. 20.74. In the year 2005, what is the difference between the Area (% of total land area) in Other small states and Area (% of total land area) in Eritrea?
Your answer should be compact. 11.85. In the year 2005, what is the difference between the Area (% of total land area) in Other small states and Area (% of total land area) in Hungary?
Your answer should be compact. 5.11. In the year 2005, what is the difference between the Area (% of total land area) of Other small states and Area (% of total land area) of Kazakhstan?
Make the answer very short. 26. In the year 2005, what is the difference between the Area (% of total land area) of Eritrea and Area (% of total land area) of Hungary?
Provide a short and direct response. -6.74. In the year 2005, what is the difference between the Area (% of total land area) in Eritrea and Area (% of total land area) in Kazakhstan?
Provide a short and direct response. 14.15. In the year 2005, what is the difference between the Area (% of total land area) of Hungary and Area (% of total land area) of Kazakhstan?
Provide a succinct answer. 20.89. In the year 2006, what is the difference between the Area (% of total land area) in Other small states and Area (% of total land area) in Eritrea?
Ensure brevity in your answer.  11.85. In the year 2006, what is the difference between the Area (% of total land area) of Other small states and Area (% of total land area) of Hungary?
Your answer should be compact. 4.92. In the year 2006, what is the difference between the Area (% of total land area) in Other small states and Area (% of total land area) in Kazakhstan?
Offer a very short reply. 25.95. In the year 2006, what is the difference between the Area (% of total land area) of Eritrea and Area (% of total land area) of Hungary?
Offer a terse response. -6.93. In the year 2006, what is the difference between the Area (% of total land area) of Eritrea and Area (% of total land area) of Kazakhstan?
Give a very brief answer. 14.11. In the year 2006, what is the difference between the Area (% of total land area) in Hungary and Area (% of total land area) in Kazakhstan?
Provide a succinct answer. 21.04. In the year 2007, what is the difference between the Area (% of total land area) in Other small states and Area (% of total land area) in Eritrea?
Offer a terse response. 11.8. In the year 2007, what is the difference between the Area (% of total land area) of Other small states and Area (% of total land area) of Hungary?
Your answer should be compact. 4.69. In the year 2007, what is the difference between the Area (% of total land area) in Other small states and Area (% of total land area) in Kazakhstan?
Your response must be concise. 25.87. In the year 2007, what is the difference between the Area (% of total land area) in Eritrea and Area (% of total land area) in Hungary?
Your answer should be compact. -7.11. In the year 2007, what is the difference between the Area (% of total land area) of Eritrea and Area (% of total land area) of Kazakhstan?
Give a very brief answer. 14.07. In the year 2007, what is the difference between the Area (% of total land area) in Hungary and Area (% of total land area) in Kazakhstan?
Give a very brief answer. 21.18. In the year 2008, what is the difference between the Area (% of total land area) in Other small states and Area (% of total land area) in Eritrea?
Provide a succinct answer. 11.75. In the year 2008, what is the difference between the Area (% of total land area) in Other small states and Area (% of total land area) in Hungary?
Provide a short and direct response. 4.46. In the year 2008, what is the difference between the Area (% of total land area) in Other small states and Area (% of total land area) in Kazakhstan?
Give a very brief answer. 25.78. In the year 2008, what is the difference between the Area (% of total land area) in Eritrea and Area (% of total land area) in Hungary?
Provide a short and direct response. -7.3. In the year 2008, what is the difference between the Area (% of total land area) of Eritrea and Area (% of total land area) of Kazakhstan?
Your answer should be compact. 14.03. In the year 2008, what is the difference between the Area (% of total land area) of Hungary and Area (% of total land area) of Kazakhstan?
Provide a short and direct response. 21.32. What is the ratio of the Area (% of total land area) of Eritrea in 2002 to that in 2003?
Your answer should be compact. 1. What is the ratio of the Area (% of total land area) in Kazakhstan in 2002 to that in 2003?
Provide a short and direct response. 1. What is the ratio of the Area (% of total land area) of Other small states in 2002 to that in 2004?
Provide a short and direct response. 1.01. What is the ratio of the Area (% of total land area) of Eritrea in 2002 to that in 2004?
Ensure brevity in your answer.  1.01. What is the ratio of the Area (% of total land area) of Hungary in 2002 to that in 2004?
Keep it short and to the point. 0.99. What is the ratio of the Area (% of total land area) in Other small states in 2002 to that in 2005?
Ensure brevity in your answer.  1.01. What is the ratio of the Area (% of total land area) of Eritrea in 2002 to that in 2005?
Your answer should be very brief. 1.01. What is the ratio of the Area (% of total land area) of Hungary in 2002 to that in 2005?
Make the answer very short. 0.98. What is the ratio of the Area (% of total land area) in Other small states in 2002 to that in 2006?
Offer a terse response. 1.01. What is the ratio of the Area (% of total land area) of Eritrea in 2002 to that in 2006?
Offer a terse response. 1.01. What is the ratio of the Area (% of total land area) of Hungary in 2002 to that in 2006?
Offer a very short reply. 0.97. What is the ratio of the Area (% of total land area) of Kazakhstan in 2002 to that in 2006?
Offer a terse response. 1.01. What is the ratio of the Area (% of total land area) in Other small states in 2002 to that in 2007?
Keep it short and to the point. 1.01. What is the ratio of the Area (% of total land area) in Eritrea in 2002 to that in 2007?
Offer a terse response. 1.01. What is the ratio of the Area (% of total land area) of Hungary in 2002 to that in 2007?
Ensure brevity in your answer.  0.97. What is the ratio of the Area (% of total land area) in Kazakhstan in 2002 to that in 2007?
Your answer should be very brief. 1.01. What is the ratio of the Area (% of total land area) of Other small states in 2002 to that in 2008?
Your response must be concise. 1.02. What is the ratio of the Area (% of total land area) of Eritrea in 2002 to that in 2008?
Make the answer very short. 1.02. What is the ratio of the Area (% of total land area) of Hungary in 2002 to that in 2008?
Provide a short and direct response. 0.96. What is the ratio of the Area (% of total land area) in Eritrea in 2003 to that in 2004?
Make the answer very short. 1. What is the ratio of the Area (% of total land area) of Kazakhstan in 2003 to that in 2004?
Keep it short and to the point. 1. What is the ratio of the Area (% of total land area) of Other small states in 2003 to that in 2005?
Give a very brief answer. 1. What is the ratio of the Area (% of total land area) in Eritrea in 2003 to that in 2005?
Your answer should be compact. 1.01. What is the ratio of the Area (% of total land area) of Hungary in 2003 to that in 2005?
Keep it short and to the point. 0.99. What is the ratio of the Area (% of total land area) in Other small states in 2003 to that in 2006?
Offer a terse response. 1.01. What is the ratio of the Area (% of total land area) of Eritrea in 2003 to that in 2006?
Make the answer very short. 1.01. What is the ratio of the Area (% of total land area) in Hungary in 2003 to that in 2006?
Provide a short and direct response. 0.98. What is the ratio of the Area (% of total land area) in Kazakhstan in 2003 to that in 2006?
Offer a terse response. 1. What is the ratio of the Area (% of total land area) in Other small states in 2003 to that in 2007?
Provide a short and direct response. 1.01. What is the ratio of the Area (% of total land area) of Eritrea in 2003 to that in 2007?
Offer a very short reply. 1.01. What is the ratio of the Area (% of total land area) in Hungary in 2003 to that in 2007?
Your answer should be very brief. 0.97. What is the ratio of the Area (% of total land area) of Other small states in 2003 to that in 2008?
Your response must be concise. 1.01. What is the ratio of the Area (% of total land area) in Eritrea in 2003 to that in 2008?
Your response must be concise. 1.01. What is the ratio of the Area (% of total land area) of Hungary in 2003 to that in 2008?
Provide a short and direct response. 0.97. What is the ratio of the Area (% of total land area) of Kazakhstan in 2003 to that in 2008?
Keep it short and to the point. 1.01. What is the ratio of the Area (% of total land area) of Hungary in 2004 to that in 2005?
Give a very brief answer. 0.99. What is the ratio of the Area (% of total land area) in Eritrea in 2004 to that in 2007?
Keep it short and to the point. 1.01. What is the ratio of the Area (% of total land area) in Hungary in 2004 to that in 2007?
Offer a terse response. 0.98. What is the ratio of the Area (% of total land area) in Other small states in 2004 to that in 2008?
Keep it short and to the point. 1.01. What is the ratio of the Area (% of total land area) in Eritrea in 2004 to that in 2008?
Keep it short and to the point. 1.01. What is the ratio of the Area (% of total land area) in Hungary in 2004 to that in 2008?
Provide a short and direct response. 0.97. What is the ratio of the Area (% of total land area) of Other small states in 2005 to that in 2006?
Your response must be concise. 1. What is the ratio of the Area (% of total land area) of Hungary in 2005 to that in 2006?
Your response must be concise. 0.99. What is the ratio of the Area (% of total land area) of Other small states in 2005 to that in 2007?
Keep it short and to the point. 1.01. What is the ratio of the Area (% of total land area) of Eritrea in 2005 to that in 2007?
Keep it short and to the point. 1.01. What is the ratio of the Area (% of total land area) in Hungary in 2005 to that in 2007?
Provide a succinct answer. 0.99. What is the ratio of the Area (% of total land area) in Kazakhstan in 2005 to that in 2007?
Offer a terse response. 1. What is the ratio of the Area (% of total land area) in Other small states in 2005 to that in 2008?
Your answer should be compact. 1.01. What is the ratio of the Area (% of total land area) of Eritrea in 2005 to that in 2008?
Your answer should be compact. 1.01. What is the ratio of the Area (% of total land area) in Hungary in 2005 to that in 2008?
Ensure brevity in your answer.  0.98. What is the ratio of the Area (% of total land area) of Other small states in 2006 to that in 2007?
Provide a succinct answer. 1. What is the ratio of the Area (% of total land area) in Hungary in 2006 to that in 2007?
Make the answer very short. 0.99. What is the ratio of the Area (% of total land area) of Other small states in 2006 to that in 2008?
Make the answer very short. 1.01. What is the ratio of the Area (% of total land area) of Hungary in 2006 to that in 2008?
Keep it short and to the point. 0.99. What is the ratio of the Area (% of total land area) of Other small states in 2007 to that in 2008?
Provide a succinct answer. 1. What is the ratio of the Area (% of total land area) in Kazakhstan in 2007 to that in 2008?
Offer a very short reply. 1. What is the difference between the highest and the second highest Area (% of total land area) in Other small states?
Give a very brief answer. 0.11. What is the difference between the highest and the second highest Area (% of total land area) in Eritrea?
Give a very brief answer. 0.04. What is the difference between the highest and the second highest Area (% of total land area) of Hungary?
Make the answer very short. 0.14. What is the difference between the highest and the second highest Area (% of total land area) of Kazakhstan?
Keep it short and to the point. 0. What is the difference between the highest and the lowest Area (% of total land area) in Other small states?
Ensure brevity in your answer.  0.45. What is the difference between the highest and the lowest Area (% of total land area) in Eritrea?
Give a very brief answer. 0.26. What is the difference between the highest and the lowest Area (% of total land area) in Hungary?
Offer a terse response. 0.87. What is the difference between the highest and the lowest Area (% of total land area) of Kazakhstan?
Your answer should be very brief. 0.01. 